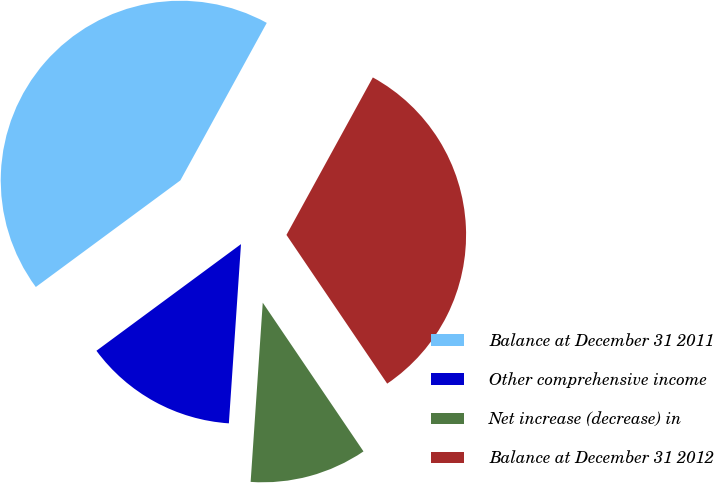Convert chart. <chart><loc_0><loc_0><loc_500><loc_500><pie_chart><fcel>Balance at December 31 2011<fcel>Other comprehensive income<fcel>Net increase (decrease) in<fcel>Balance at December 31 2012<nl><fcel>43.1%<fcel>13.81%<fcel>10.55%<fcel>32.54%<nl></chart> 